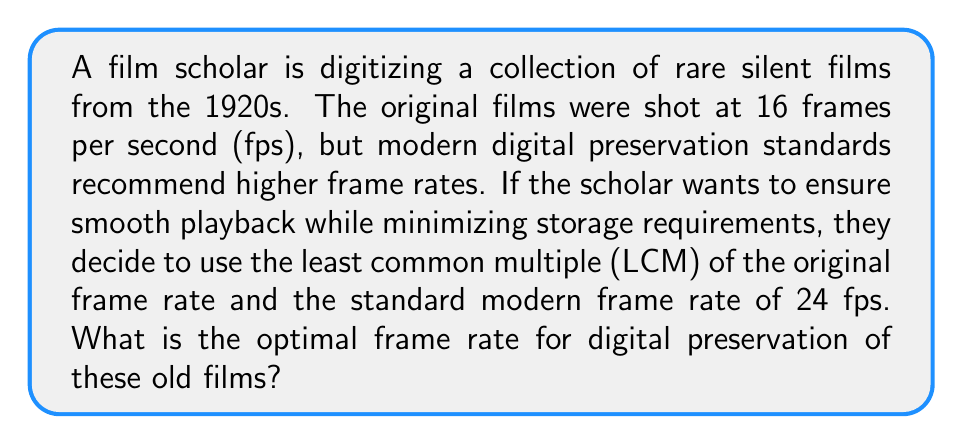What is the answer to this math problem? To solve this problem, we need to find the least common multiple (LCM) of 16 fps and 24 fps. This will ensure that the new frame rate is divisible by both the original and modern standard rates, allowing for smooth playback at either speed.

Let's approach this step-by-step:

1) First, let's find the prime factorization of both numbers:
   
   16 = $2^4$
   24 = $2^3 \times 3$

2) The LCM will include the highest power of each prime factor from either number. So we need:
   
   $2^4$ (from 16, as it's higher than $2^3$ in 24)
   $3^1$ (from 24)

3) Now, let's multiply these factors:

   $LCM = 2^4 \times 3^1 = 16 \times 3 = 48$

Therefore, the optimal frame rate for digital preservation that satisfies both the original frame rate and the modern standard is 48 fps.

This frame rate allows for perfect playback at both 16 fps (by showing each frame 3 times) and 24 fps (by showing each frame 2 times), while also providing a higher quality preservation format.
Answer: 48 fps 